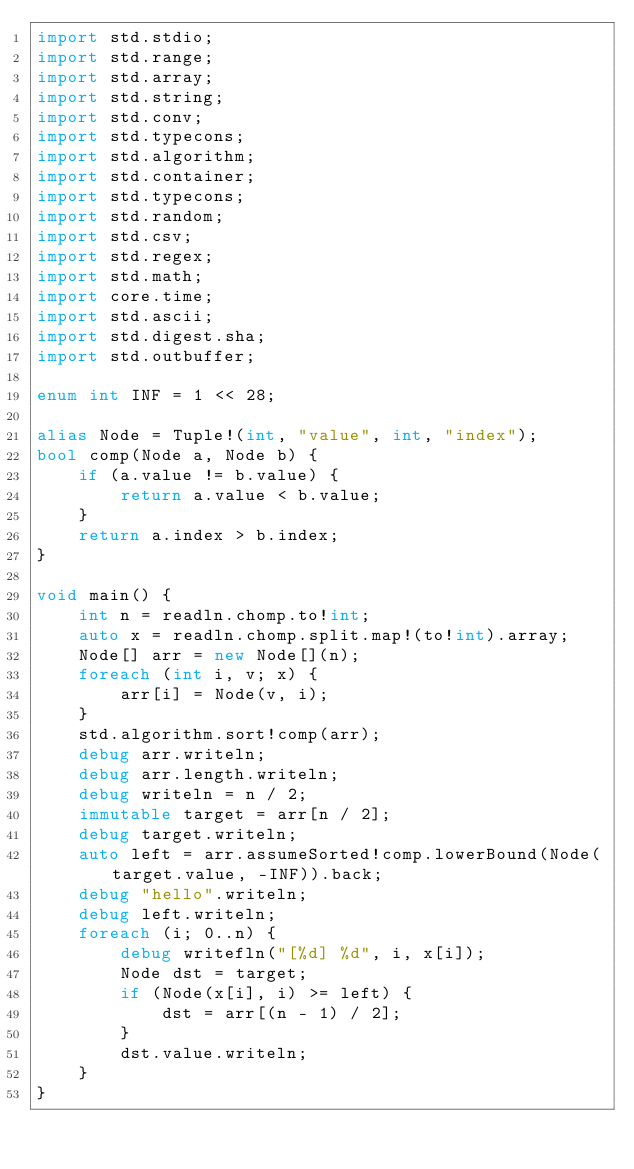Convert code to text. <code><loc_0><loc_0><loc_500><loc_500><_D_>import std.stdio;
import std.range;
import std.array;
import std.string;
import std.conv;
import std.typecons;
import std.algorithm;
import std.container;
import std.typecons;
import std.random;
import std.csv;
import std.regex;
import std.math;
import core.time;
import std.ascii;
import std.digest.sha;
import std.outbuffer;

enum int INF = 1 << 28;

alias Node = Tuple!(int, "value", int, "index");
bool comp(Node a, Node b) {
	if (a.value != b.value) {
		return a.value < b.value;
	}
	return a.index > b.index;
}

void main() {
	int n = readln.chomp.to!int;
	auto x = readln.chomp.split.map!(to!int).array;
	Node[] arr = new Node[](n);
	foreach (int i, v; x) {
		arr[i] = Node(v, i);
	}
	std.algorithm.sort!comp(arr);
	debug arr.writeln;
	debug arr.length.writeln;
	debug writeln = n / 2;
	immutable target = arr[n / 2];
	debug target.writeln;
	auto left = arr.assumeSorted!comp.lowerBound(Node(target.value, -INF)).back;
	debug "hello".writeln;
	debug left.writeln;
	foreach (i; 0..n) {
		debug writefln("[%d] %d", i, x[i]);
		Node dst = target;
		if (Node(x[i], i) >= left) {
			dst = arr[(n - 1) / 2];
		}
		dst.value.writeln;
	}
}

</code> 